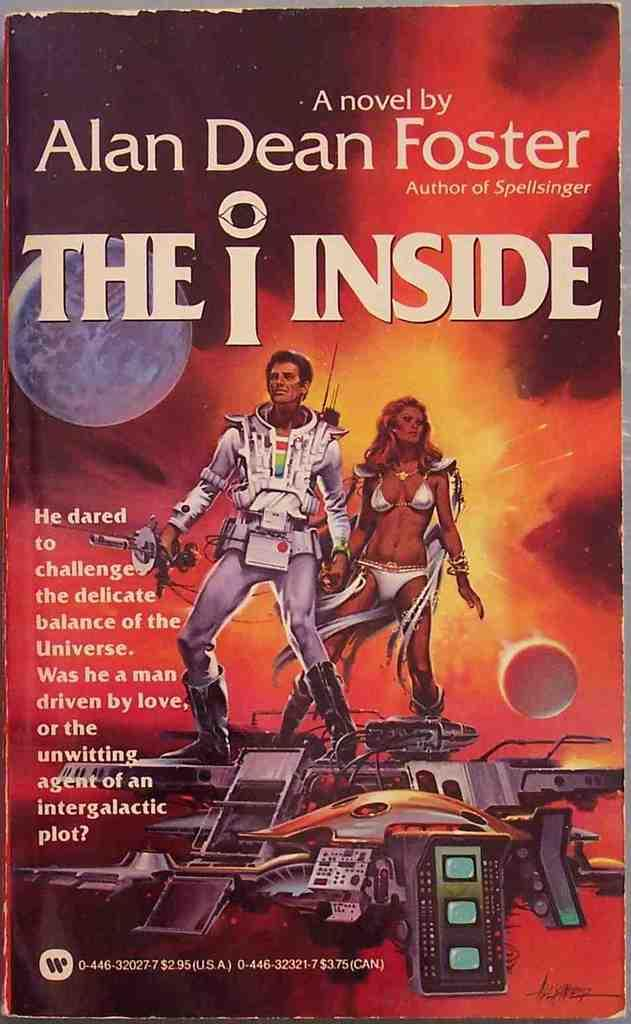Provide a one-sentence caption for the provided image. The book The I Inside, By Alan Dean Foster. 